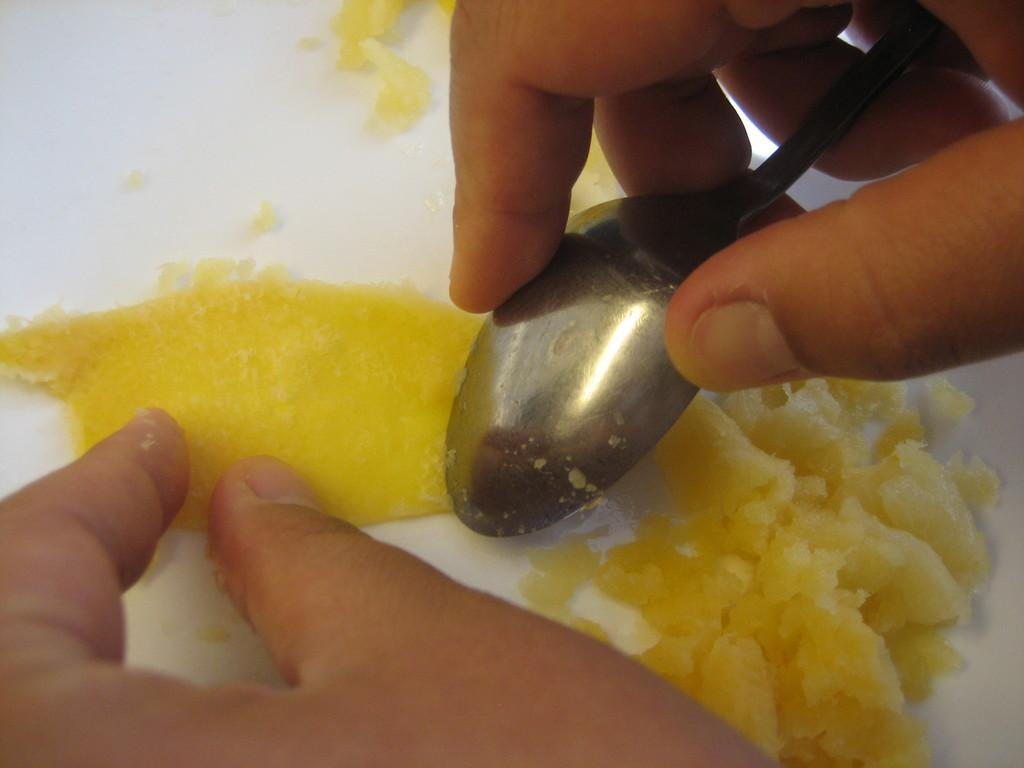What is the main subject of the image? There is a person in the image. What is the person holding in the image? The person is holding a spoon. What action is the person performing in the image? The person is peeling an object. What is the color of the object being peeled? The object being peeled is yellow in color. How many peace symbols can be seen in the image? There are no peace symbols present in the image. What type of ticket is the person holding in the image? There is no ticket present in the image; the person is holding a spoon and peeling a yellow object. 